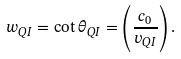Convert formula to latex. <formula><loc_0><loc_0><loc_500><loc_500>w _ { Q I } = \cot { \theta _ { Q I } } = \left ( \frac { c _ { 0 } } { v _ { Q I } } \right ) .</formula> 